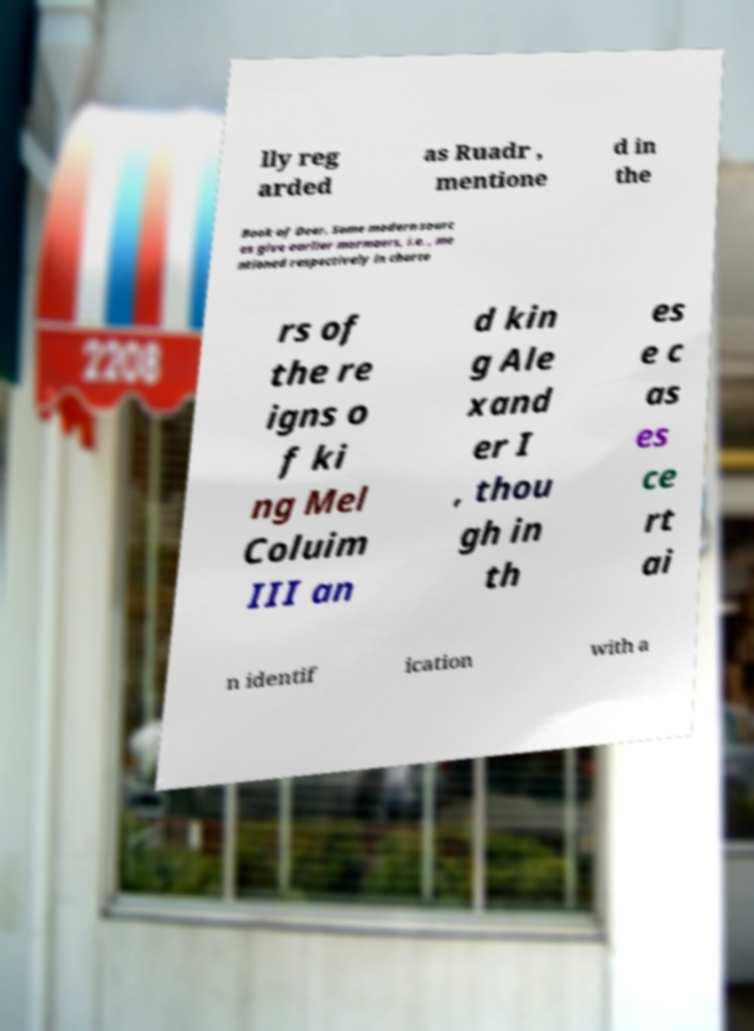Please identify and transcribe the text found in this image. lly reg arded as Ruadr , mentione d in the Book of Deer. Some modern sourc es give earlier mormaers, i.e. , me ntioned respectively in charte rs of the re igns o f ki ng Mel Coluim III an d kin g Ale xand er I , thou gh in th es e c as es ce rt ai n identif ication with a 